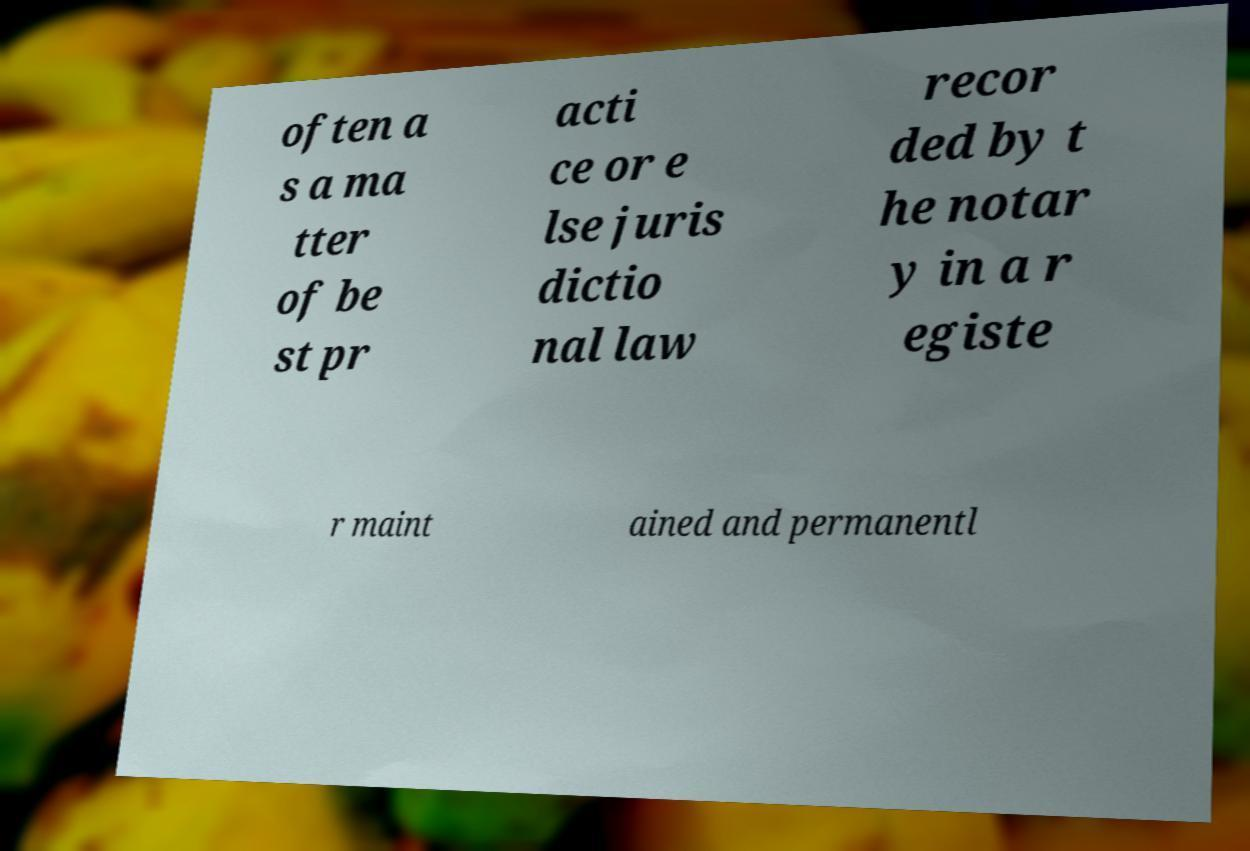I need the written content from this picture converted into text. Can you do that? often a s a ma tter of be st pr acti ce or e lse juris dictio nal law recor ded by t he notar y in a r egiste r maint ained and permanentl 